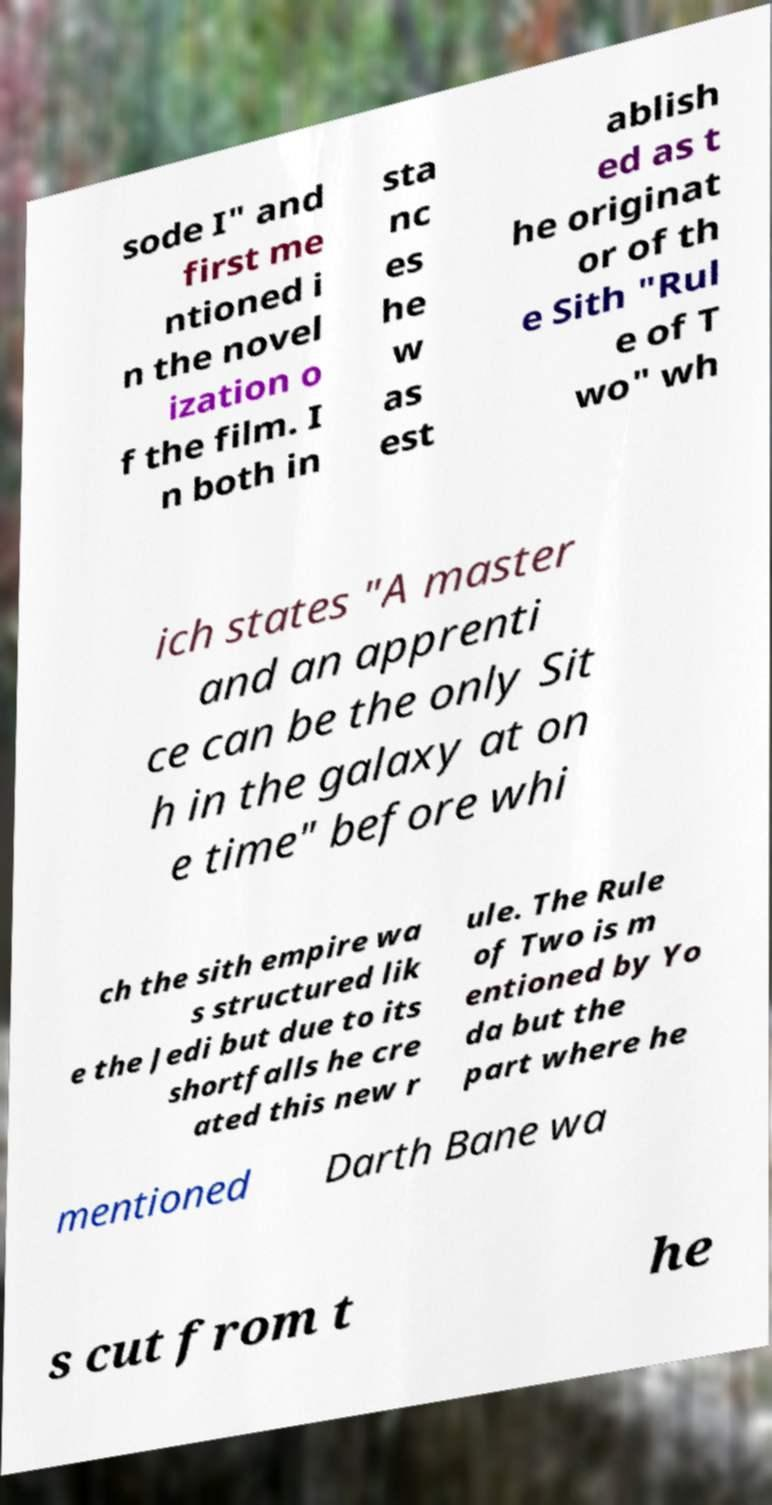Could you extract and type out the text from this image? sode I" and first me ntioned i n the novel ization o f the film. I n both in sta nc es he w as est ablish ed as t he originat or of th e Sith "Rul e of T wo" wh ich states "A master and an apprenti ce can be the only Sit h in the galaxy at on e time" before whi ch the sith empire wa s structured lik e the Jedi but due to its shortfalls he cre ated this new r ule. The Rule of Two is m entioned by Yo da but the part where he mentioned Darth Bane wa s cut from t he 